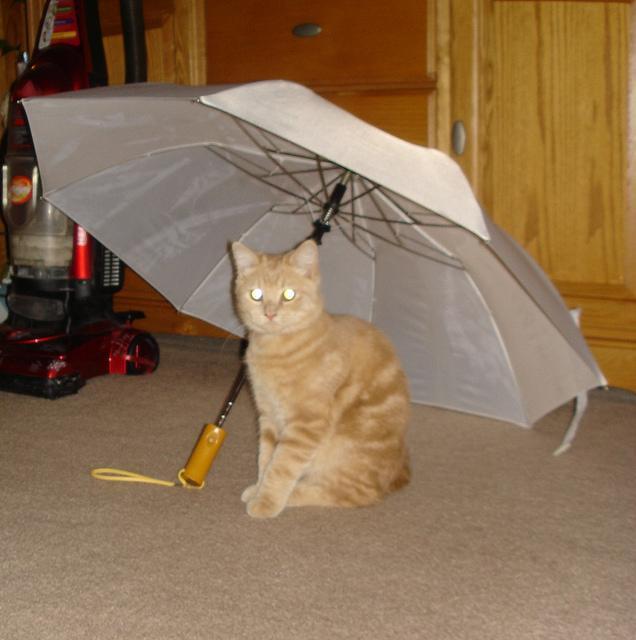How many cars are moving?
Give a very brief answer. 0. 